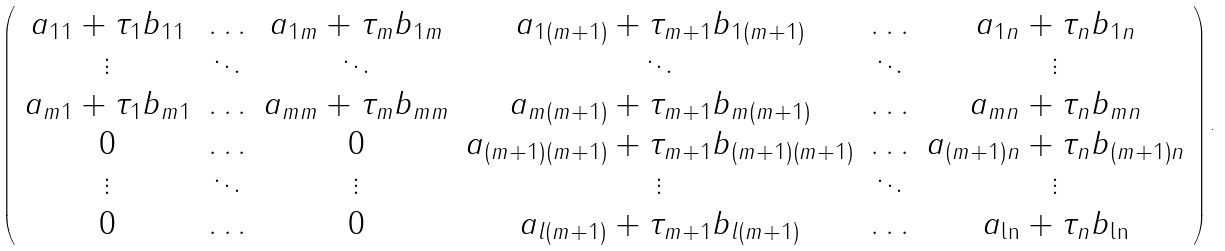<formula> <loc_0><loc_0><loc_500><loc_500>\left ( \begin{array} { c c c c c c } a _ { 1 1 } + \tau _ { 1 } b _ { 1 1 } & \hdots & a _ { 1 m } + \tau _ { m } b _ { 1 m } & a _ { 1 ( m + 1 ) } + \tau _ { m + 1 } b _ { 1 ( m + 1 ) } & \hdots & a _ { 1 n } + \tau _ { n } b _ { 1 n } \\ \vdots & \ddots & \ddots & \ddots & \ddots & \vdots \\ a _ { m 1 } + \tau _ { 1 } b _ { m 1 } & \hdots & a _ { m m } + \tau _ { m } b _ { m m } & a _ { m ( m + 1 ) } + \tau _ { m + 1 } b _ { m ( m + 1 ) } & \hdots & a _ { m n } + \tau _ { n } b _ { m n } \\ 0 & \hdots & 0 & a _ { ( m + 1 ) ( m + 1 ) } + \tau _ { m + 1 } b _ { ( m + 1 ) ( m + 1 ) } & \hdots & a _ { ( m + 1 ) n } + \tau _ { n } b _ { ( m + 1 ) n } \\ \vdots & \ddots & \vdots & \vdots & \ddots & \vdots \\ 0 & \hdots & 0 & a _ { l ( m + 1 ) } + \tau _ { m + 1 } b _ { l ( m + 1 ) } & \hdots & a _ { \ln } + \tau _ { n } b _ { \ln } \end{array} \right ) .</formula> 